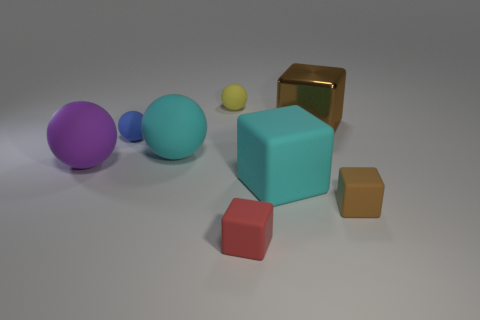Subtract 1 blocks. How many blocks are left? 3 Add 1 blue matte balls. How many objects exist? 9 Subtract all red matte things. Subtract all small blue spheres. How many objects are left? 6 Add 4 small yellow matte things. How many small yellow matte things are left? 5 Add 1 tiny red cubes. How many tiny red cubes exist? 2 Subtract 1 cyan spheres. How many objects are left? 7 